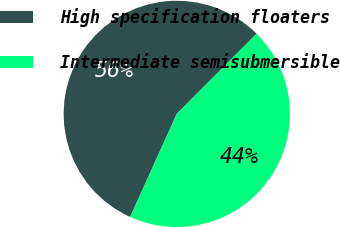<chart> <loc_0><loc_0><loc_500><loc_500><pie_chart><fcel>High specification floaters<fcel>Intermediate semisubmersible<nl><fcel>55.7%<fcel>44.3%<nl></chart> 